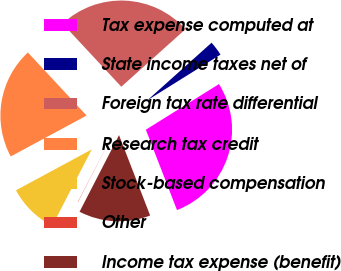<chart> <loc_0><loc_0><loc_500><loc_500><pie_chart><fcel>Tax expense computed at<fcel>State income taxes net of<fcel>Foreign tax rate differential<fcel>Research tax credit<fcel>Stock-based compensation<fcel>Other<fcel>Income tax expense (benefit)<nl><fcel>28.0%<fcel>2.75%<fcel>25.3%<fcel>20.94%<fcel>9.51%<fcel>0.05%<fcel>13.45%<nl></chart> 